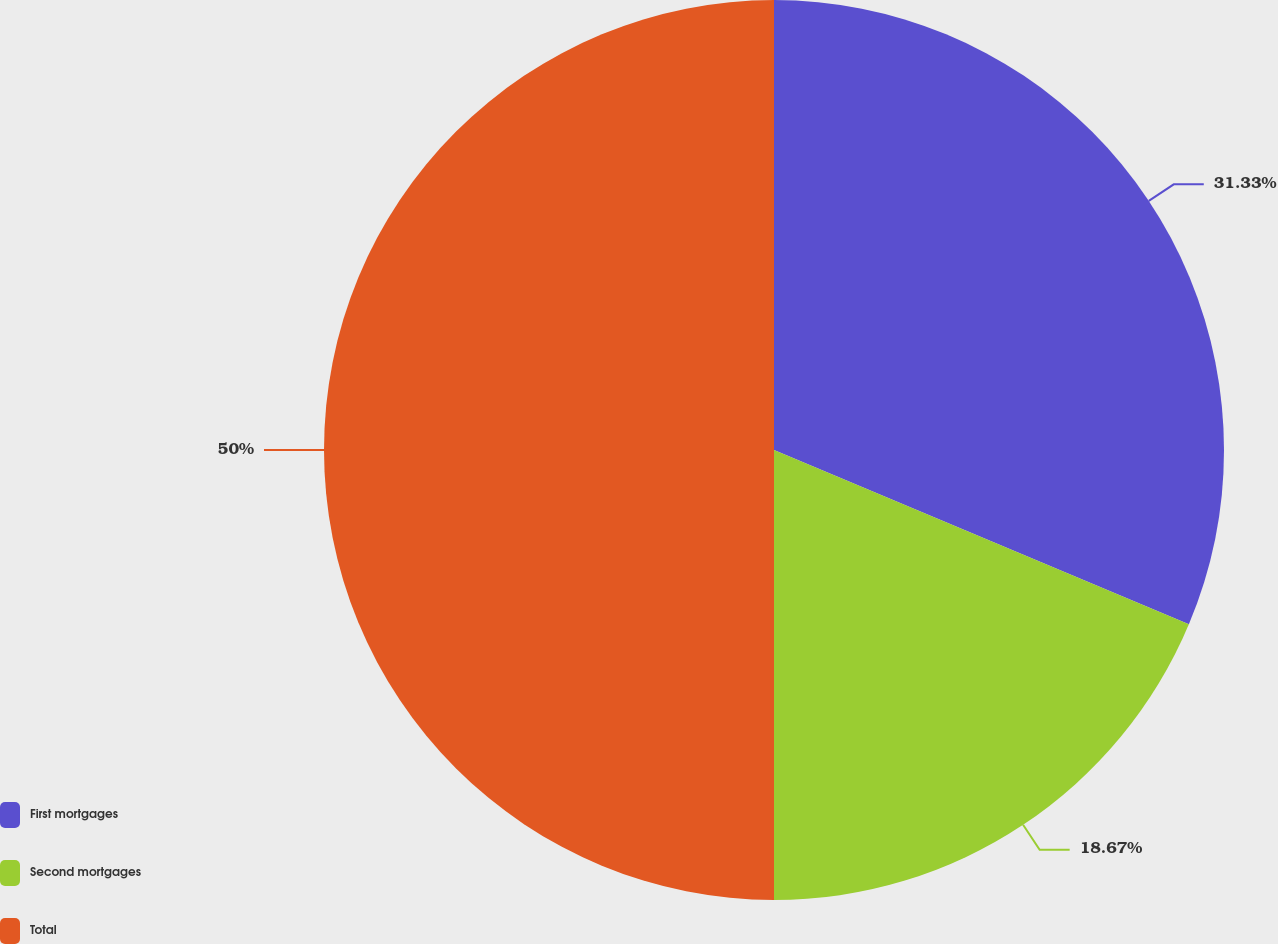Convert chart to OTSL. <chart><loc_0><loc_0><loc_500><loc_500><pie_chart><fcel>First mortgages<fcel>Second mortgages<fcel>Total<nl><fcel>31.33%<fcel>18.67%<fcel>50.0%<nl></chart> 